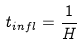<formula> <loc_0><loc_0><loc_500><loc_500>t _ { i n f l } = \frac { 1 } { H }</formula> 